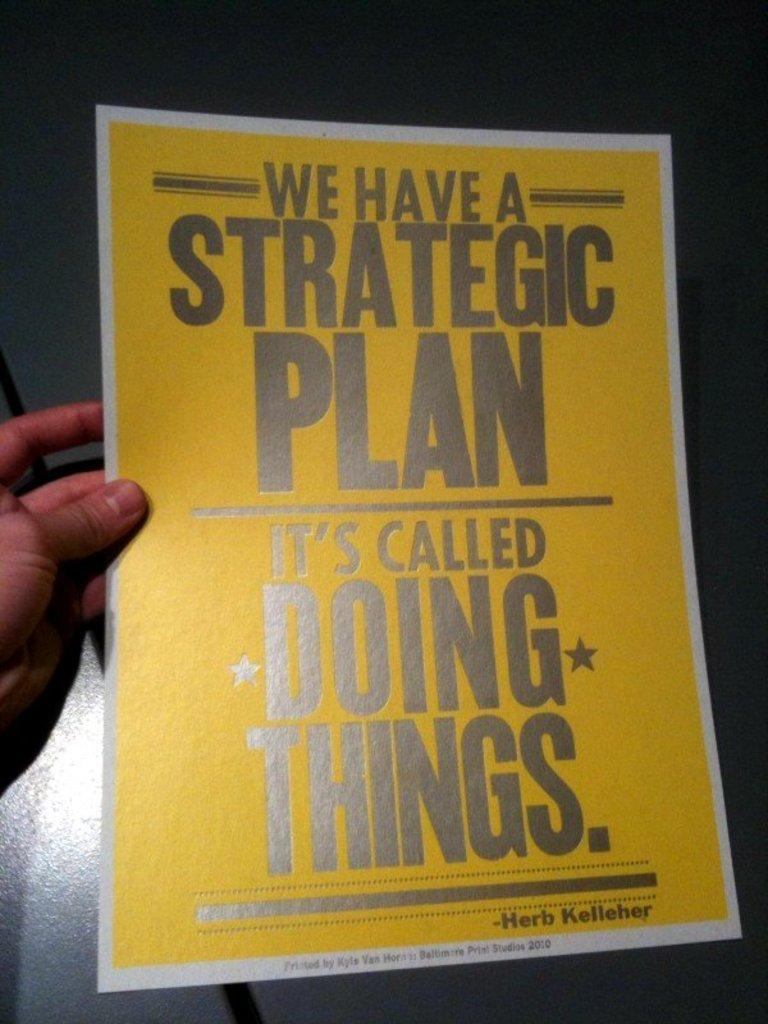<image>
Give a short and clear explanation of the subsequent image. a poster of it's called doing things in yellow 